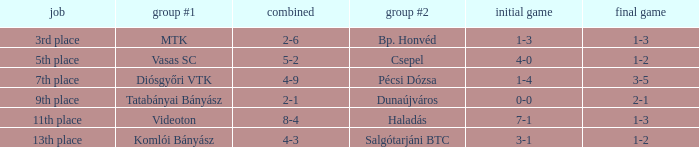How many positions correspond to a 1-3 1st leg? 1.0. 